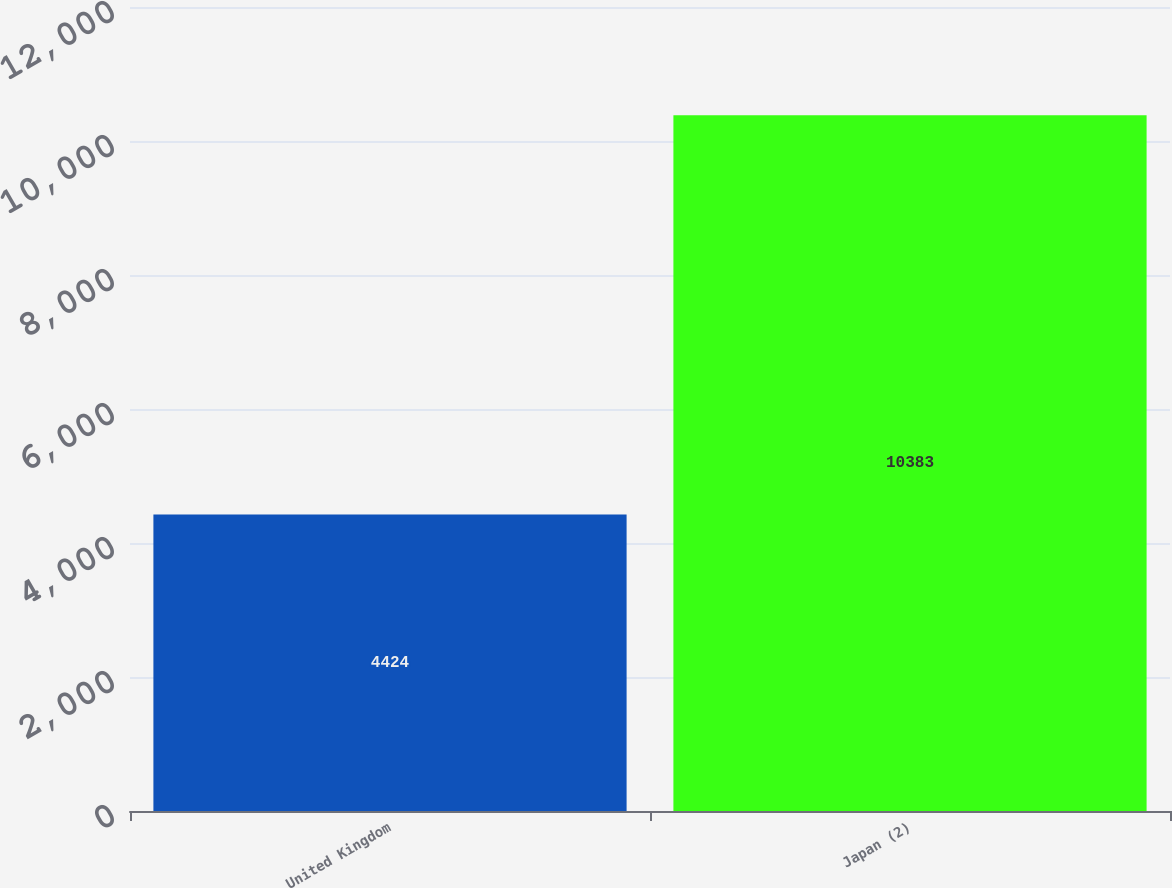Convert chart. <chart><loc_0><loc_0><loc_500><loc_500><bar_chart><fcel>United Kingdom<fcel>Japan (2)<nl><fcel>4424<fcel>10383<nl></chart> 